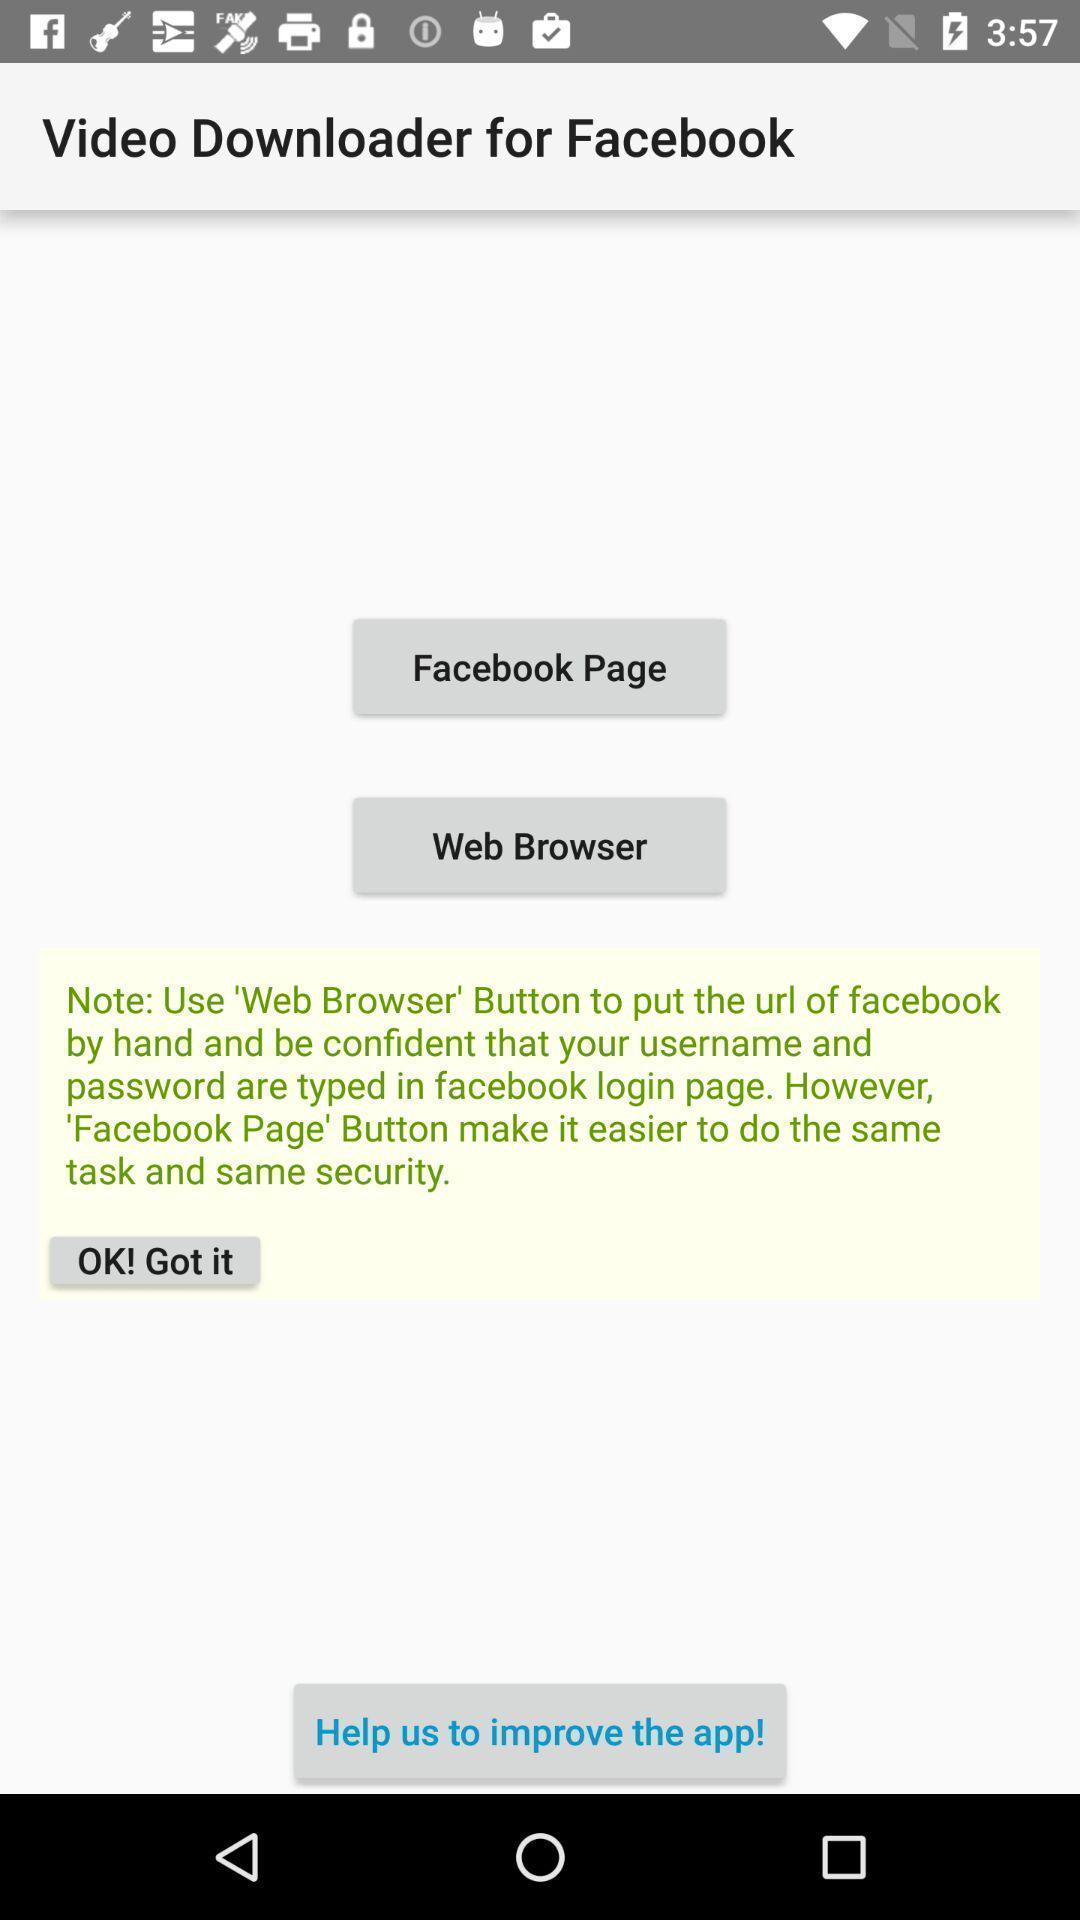Tell me about the visual elements in this screen capture. Page showing different options in application. 